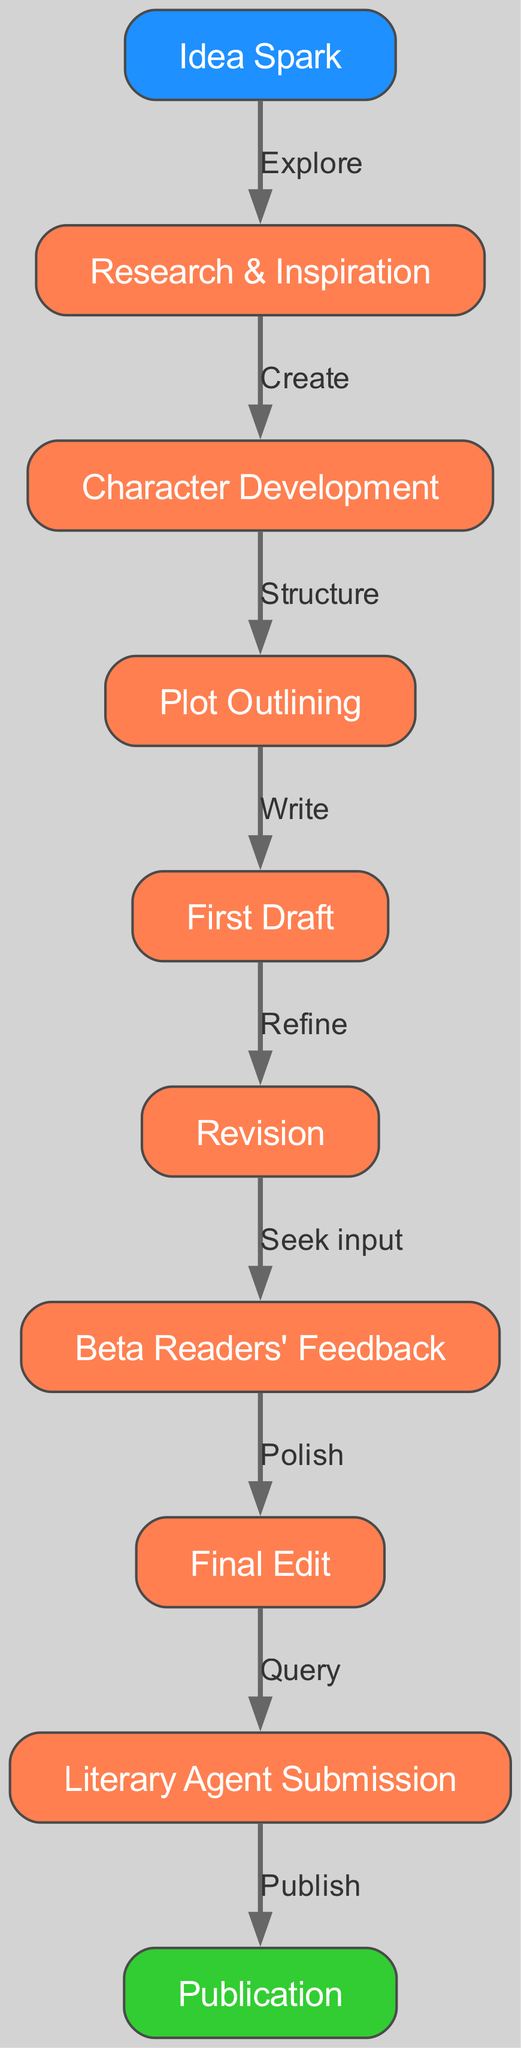What is the first step in the writing process? The first node in the diagram is labeled "Idea Spark," indicating that this is where the writing process begins.
Answer: Idea Spark How many nodes are depicted in the diagram? The diagram contains a total of ten nodes, each representing different stages in the writing process from idea conception to publication.
Answer: 10 What label is associated with the edge connecting nodes 1 and 2? The edge from "Idea Spark" to "Research & Inspiration" is labeled "Explore," indicating the action taken between these two stages.
Answer: Explore What comes after "First Draft"? Following "First Draft," the next node is "Revision," showing the progression from completing a draft to refining it based on evaluations.
Answer: Revision How is reader feedback incorporated in the writing process? The diagram shows that after "Revision," the writer seeks input from "Beta Readers' Feedback," highlighting the importance of external perspectives before moving on.
Answer: Seek input What labeling indicates the final stage of the process? The last node in the flowchart is labeled "Publication," which signifies the culmination of the writing process, where the work is shared with the public.
Answer: Publication How many edges connect the nodes in the diagram? There are nine edges in total, representing the actions or transitions between the ten nodes throughout the writing process.
Answer: 9 What phase immediately precedes "Final Edit"? "Beta Readers' Feedback" is the step that comes right before "Final Edit," demonstrating the importance of critique before finalizing the work.
Answer: Beta Readers' Feedback What transitional action occurs between "Plot Outlining" and "First Draft"? The transition from "Plot Outlining" to "First Draft" is marked by the action "Write," indicating the process of translating the outline into a written draft.
Answer: Write 